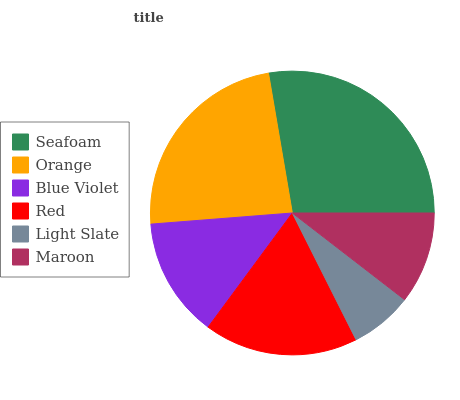Is Light Slate the minimum?
Answer yes or no. Yes. Is Seafoam the maximum?
Answer yes or no. Yes. Is Orange the minimum?
Answer yes or no. No. Is Orange the maximum?
Answer yes or no. No. Is Seafoam greater than Orange?
Answer yes or no. Yes. Is Orange less than Seafoam?
Answer yes or no. Yes. Is Orange greater than Seafoam?
Answer yes or no. No. Is Seafoam less than Orange?
Answer yes or no. No. Is Red the high median?
Answer yes or no. Yes. Is Blue Violet the low median?
Answer yes or no. Yes. Is Maroon the high median?
Answer yes or no. No. Is Orange the low median?
Answer yes or no. No. 